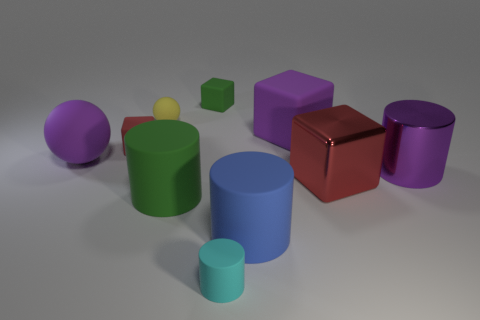Subtract all red blocks. How many were subtracted if there are1red blocks left? 1 Subtract all blocks. How many objects are left? 6 Add 6 big blocks. How many big blocks exist? 8 Subtract 0 cyan balls. How many objects are left? 10 Subtract all large rubber cubes. Subtract all big blue objects. How many objects are left? 8 Add 5 yellow matte spheres. How many yellow matte spheres are left? 6 